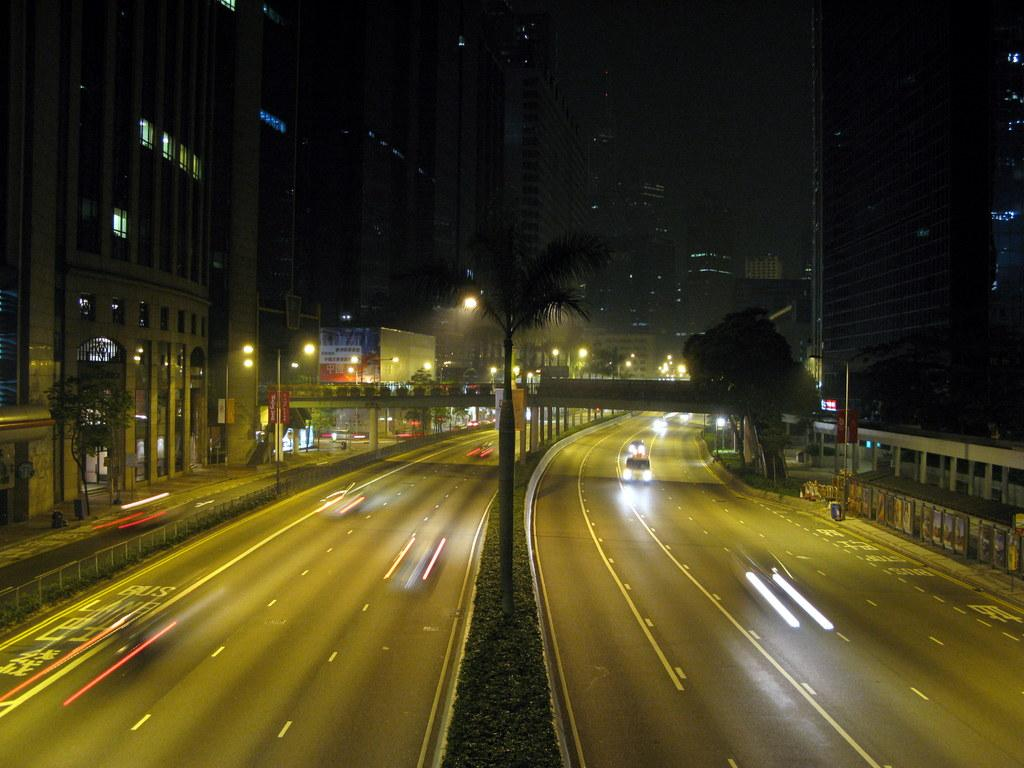What can be seen on the roads in the image? There are vehicles on the roads in the image. What type of natural elements can be seen in the background of the image? There are trees in the background of the image. What type of man-made structures can be seen in the background of the image? There are buildings in the background of the image. What type of lighting is present in the background of the image? Street lights are present in the background of the image. What type of barrier is visible in the background of the image? There is a fence in the background of the image. What other objects can be seen in the background of the image? There are other objects visible in the background of the image. Where is the nest of the creator in the image? There is no nest or creator present in the image. What type of skin is visible on the vehicles in the image? The vehicles in the image do not have skin; they are made of metal or other materials. 